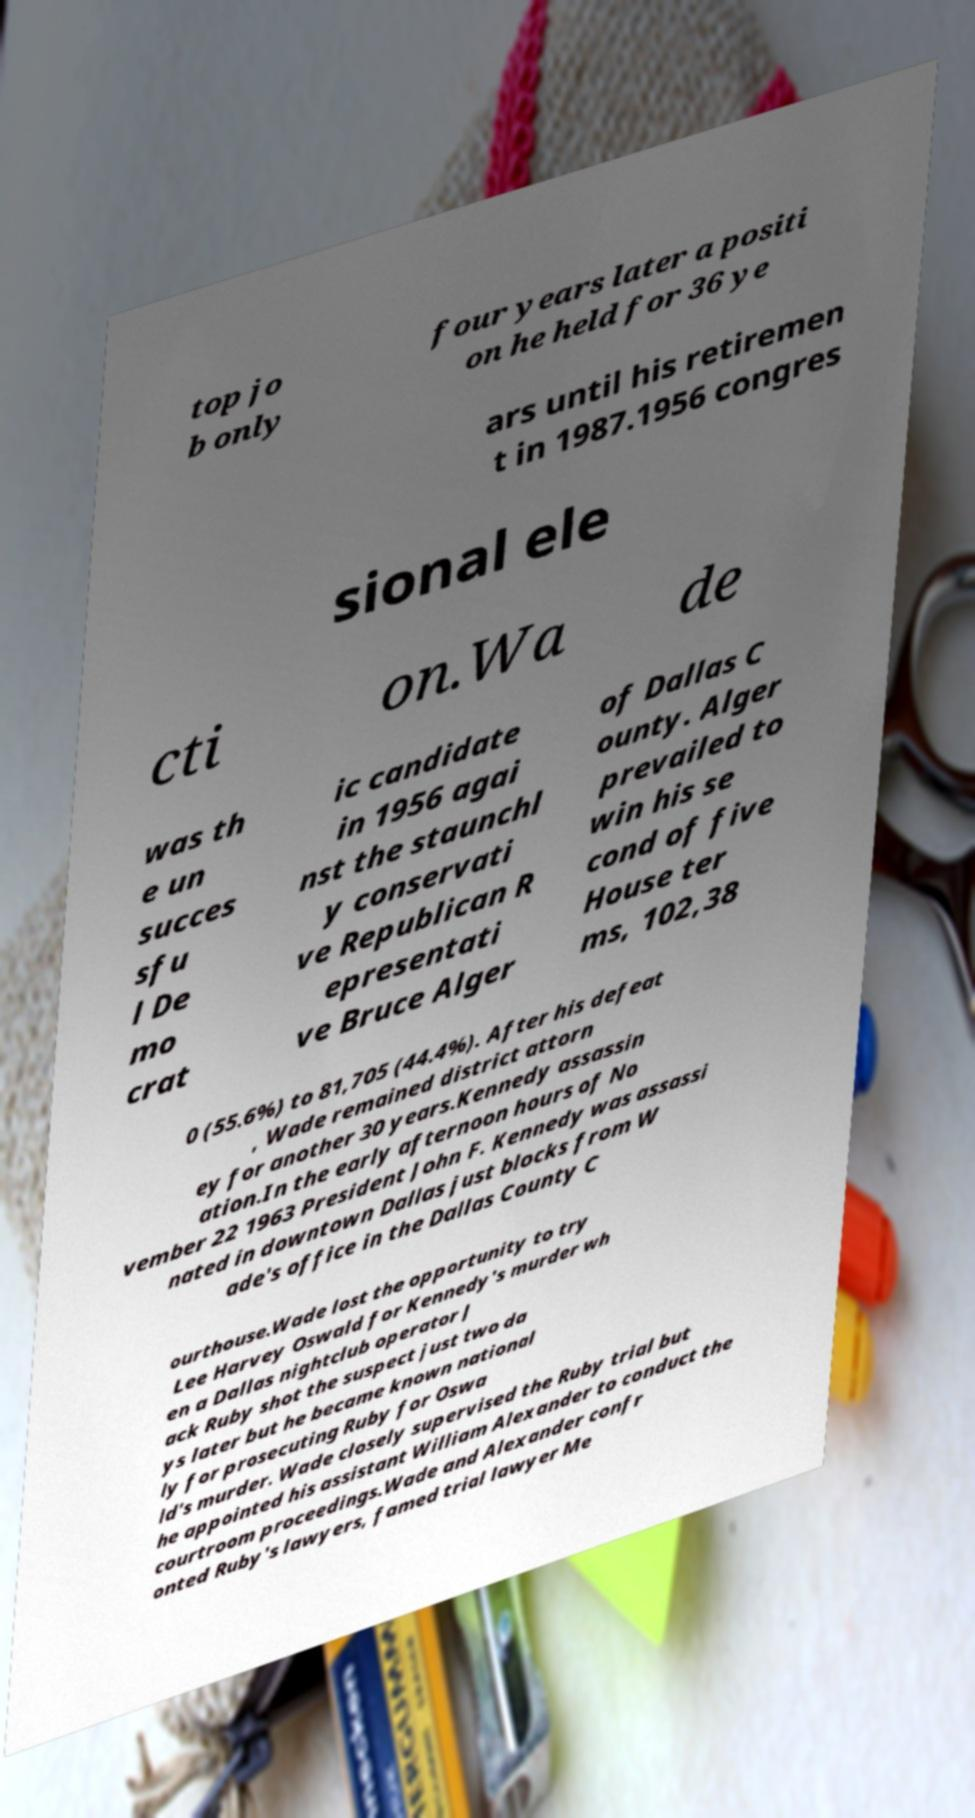Can you accurately transcribe the text from the provided image for me? top jo b only four years later a positi on he held for 36 ye ars until his retiremen t in 1987.1956 congres sional ele cti on.Wa de was th e un succes sfu l De mo crat ic candidate in 1956 agai nst the staunchl y conservati ve Republican R epresentati ve Bruce Alger of Dallas C ounty. Alger prevailed to win his se cond of five House ter ms, 102,38 0 (55.6%) to 81,705 (44.4%). After his defeat , Wade remained district attorn ey for another 30 years.Kennedy assassin ation.In the early afternoon hours of No vember 22 1963 President John F. Kennedy was assassi nated in downtown Dallas just blocks from W ade's office in the Dallas County C ourthouse.Wade lost the opportunity to try Lee Harvey Oswald for Kennedy's murder wh en a Dallas nightclub operator J ack Ruby shot the suspect just two da ys later but he became known national ly for prosecuting Ruby for Oswa ld's murder. Wade closely supervised the Ruby trial but he appointed his assistant William Alexander to conduct the courtroom proceedings.Wade and Alexander confr onted Ruby's lawyers, famed trial lawyer Me 